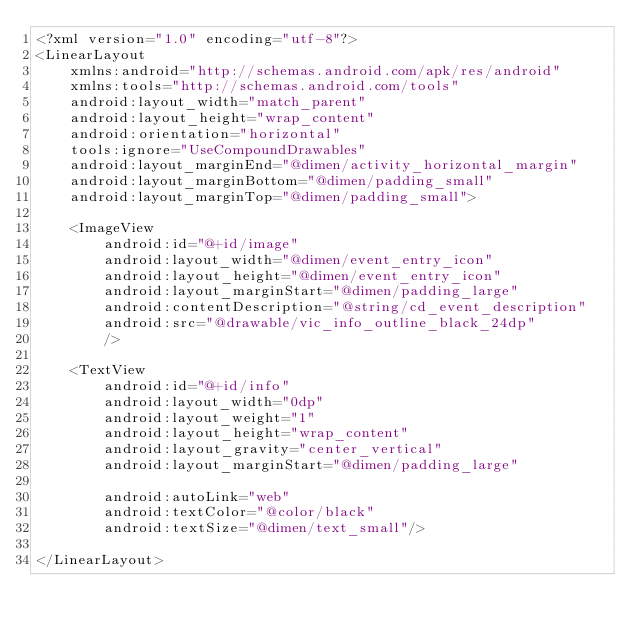<code> <loc_0><loc_0><loc_500><loc_500><_XML_><?xml version="1.0" encoding="utf-8"?>
<LinearLayout
    xmlns:android="http://schemas.android.com/apk/res/android"
    xmlns:tools="http://schemas.android.com/tools"
    android:layout_width="match_parent"
    android:layout_height="wrap_content"
    android:orientation="horizontal"
    tools:ignore="UseCompoundDrawables"
    android:layout_marginEnd="@dimen/activity_horizontal_margin"
    android:layout_marginBottom="@dimen/padding_small"
    android:layout_marginTop="@dimen/padding_small">

    <ImageView
        android:id="@+id/image"
        android:layout_width="@dimen/event_entry_icon"
        android:layout_height="@dimen/event_entry_icon"
        android:layout_marginStart="@dimen/padding_large"
        android:contentDescription="@string/cd_event_description"
        android:src="@drawable/vic_info_outline_black_24dp"
        />

    <TextView
        android:id="@+id/info"
        android:layout_width="0dp"
        android:layout_weight="1"
        android:layout_height="wrap_content"
        android:layout_gravity="center_vertical"
        android:layout_marginStart="@dimen/padding_large"

        android:autoLink="web"
        android:textColor="@color/black"
        android:textSize="@dimen/text_small"/>

</LinearLayout></code> 